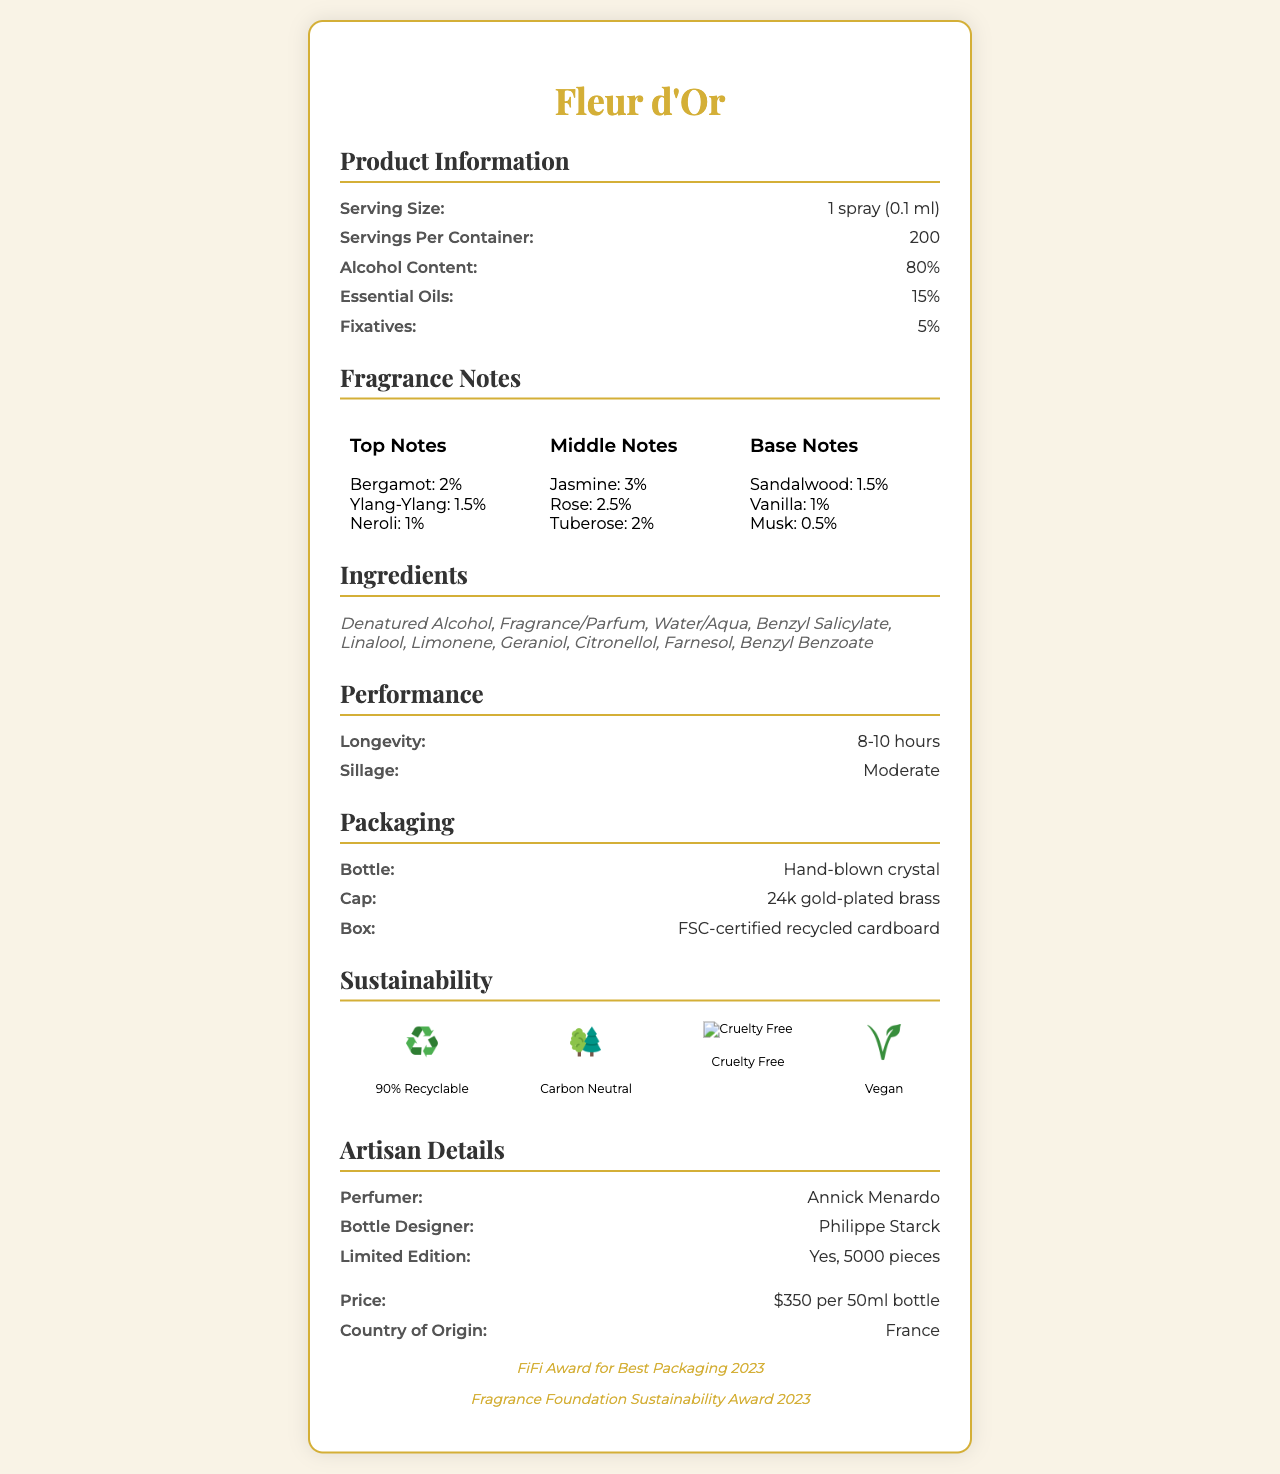how many sprays are there per container? According to the document, "Servings Per Container" is listed as 200, which means there are 200 sprays per container.
Answer: 200 what is the essential oils percentage? The document states that the "Essential Oils" content is 15%.
Answer: 15% name any three ingredients in this perfume The document lists the ingredients, including Denatured Alcohol, Fragrance/Parfum, and Water/Aqua.
Answer: Denatured Alcohol, Fragrance/Parfum, Water/Aqua what are the top notes of Fleur d'Or? The document mentions the top notes and their respective percentages: Bergamot (2%), Ylang-Ylang (1.5%), and Neroli (1%).
Answer: Bergamot, Ylang-Ylang, Neroli what is the price of a 50ml bottle of Fleur d'Or? The document states that the price is "$350 per 50ml bottle".
Answer: $350 which category has the most notes in Fleur d'Or? A. Top Notes B. Middle Notes C. Base Notes The middle notes category has the highest total percentage with Jasmine (3%), Rose (2.5%), and Tuberose (2%).
Answer: B how long does the longevity of the perfume last? A. 4-6 hours B. 6-8 hours C. 8-10 hours The document states the longevity is "8-10 hours".
Answer: C is the perfume cruelty-free? The sustainability section of the document lists the perfume as "Cruelty Free: Yes".
Answer: Yes what material is the cap of the bottle made from? The document specifies that the cap material is "24k gold-plated brass".
Answer: 24k gold-plated brass summarize the main features of Fleur d'Or The document describes the perfume's notes, packaging, sustainability features, and pricing. It mentions that it is made from fine materials and has won awards for its packaging and sustainability.
Answer: Fleur d'Or is a luxury perfume with 80% alcohol content, featuring floral notes like Bergamot and Jasmine. It comes in a hand-blown crystal bottle with a 24k gold-plated brass cap. The packaging is sustainable, being 90% recyclable, and the product is cruelty-free and vegan. Each 50ml bottle costs $350. who is the target consumer for this product? The document does not provide specific details about the target consumer for Fleur d'Or.
Answer: Not enough information 